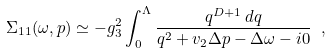Convert formula to latex. <formula><loc_0><loc_0><loc_500><loc_500>\Sigma _ { 1 1 } ( \omega , { p } ) \simeq - g _ { 3 } ^ { 2 } \int _ { 0 } ^ { \Lambda } \frac { q ^ { D + 1 } \, d q } { q ^ { 2 } + { v } _ { 2 } \Delta { p } - \Delta \omega - i 0 } \ ,</formula> 